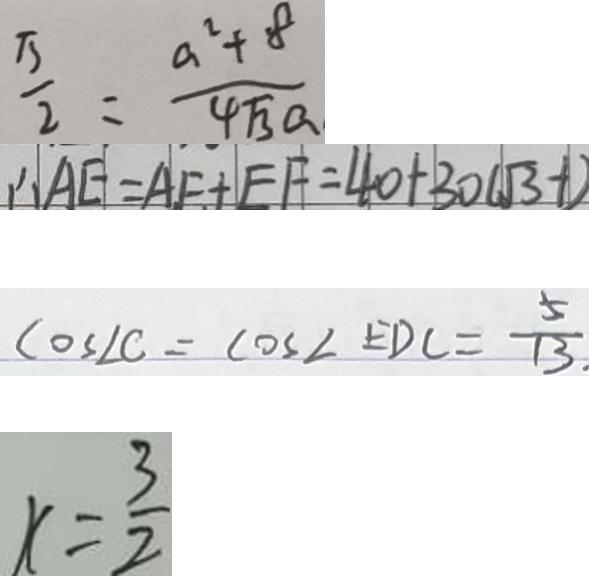<formula> <loc_0><loc_0><loc_500><loc_500>\frac { \pi } { 2 } = \frac { a ^ { 2 } + 8 } { 4 \sqrt { 3 } a } 
 \therefore A E = A F + E F = 4 0 + 3 0 ( \sqrt { 3 } - 1 ) 
 \cos \angle C = \cos \angle E D C = \frac { 5 } { 1 3 } . 
 r = \frac { 3 } { 2 }</formula> 